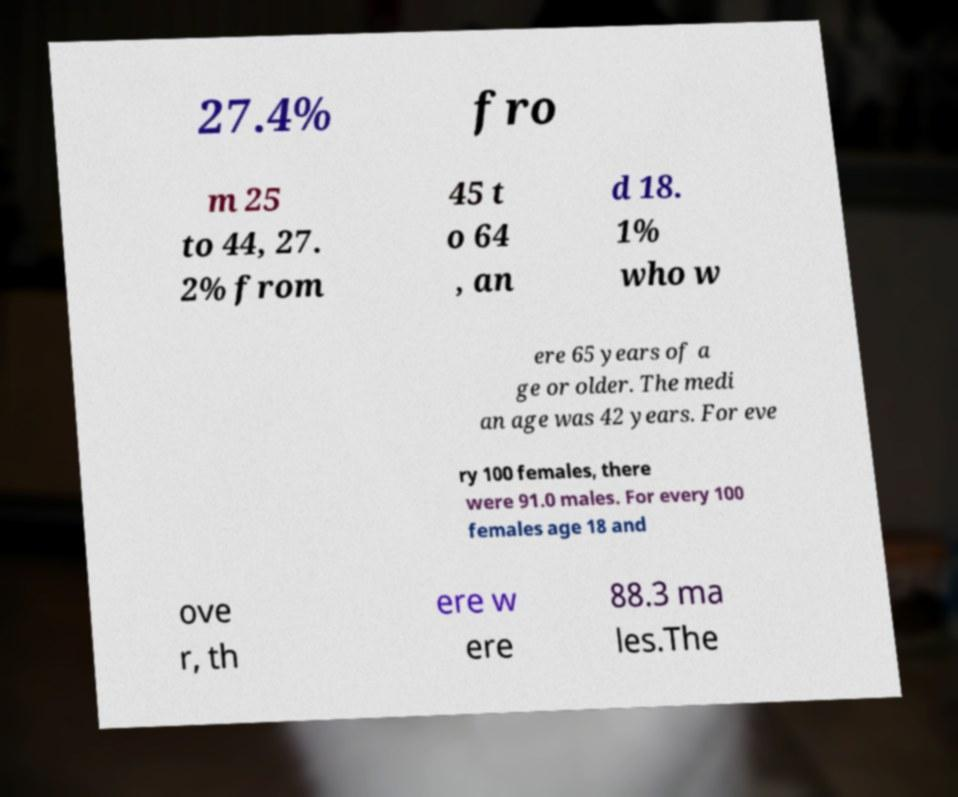Could you extract and type out the text from this image? 27.4% fro m 25 to 44, 27. 2% from 45 t o 64 , an d 18. 1% who w ere 65 years of a ge or older. The medi an age was 42 years. For eve ry 100 females, there were 91.0 males. For every 100 females age 18 and ove r, th ere w ere 88.3 ma les.The 